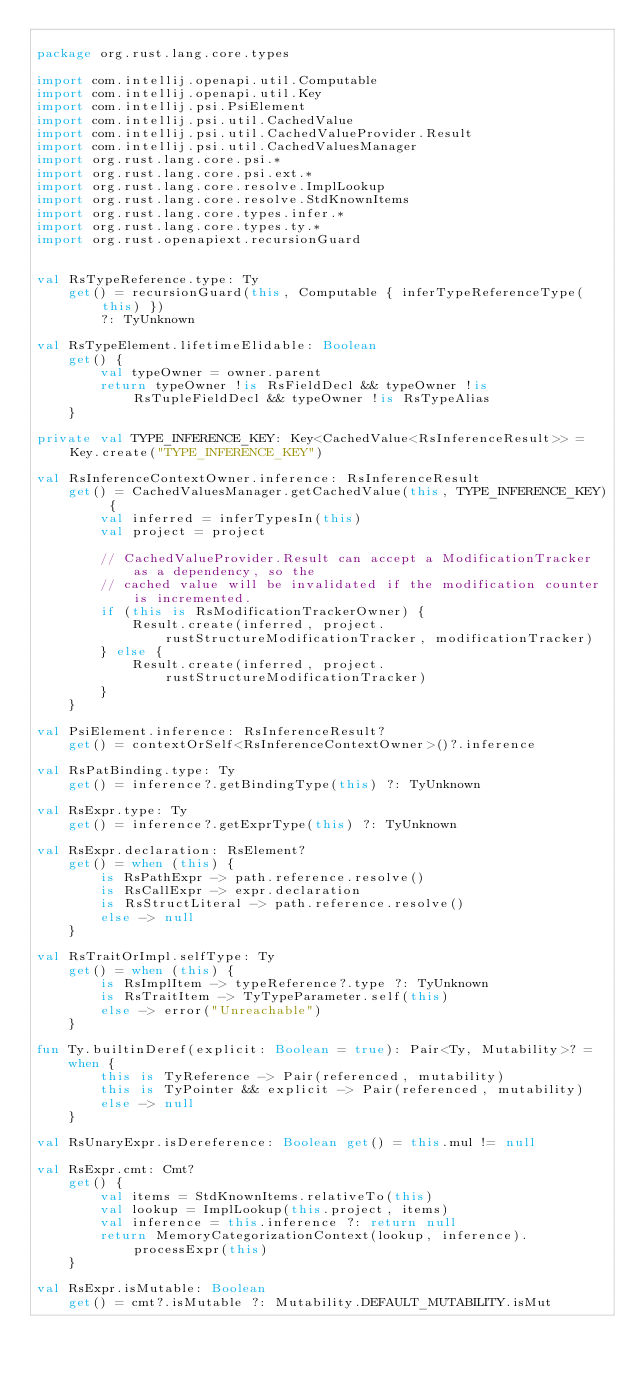Convert code to text. <code><loc_0><loc_0><loc_500><loc_500><_Kotlin_>
package org.rust.lang.core.types

import com.intellij.openapi.util.Computable
import com.intellij.openapi.util.Key
import com.intellij.psi.PsiElement
import com.intellij.psi.util.CachedValue
import com.intellij.psi.util.CachedValueProvider.Result
import com.intellij.psi.util.CachedValuesManager
import org.rust.lang.core.psi.*
import org.rust.lang.core.psi.ext.*
import org.rust.lang.core.resolve.ImplLookup
import org.rust.lang.core.resolve.StdKnownItems
import org.rust.lang.core.types.infer.*
import org.rust.lang.core.types.ty.*
import org.rust.openapiext.recursionGuard


val RsTypeReference.type: Ty
    get() = recursionGuard(this, Computable { inferTypeReferenceType(this) })
        ?: TyUnknown

val RsTypeElement.lifetimeElidable: Boolean
    get() {
        val typeOwner = owner.parent
        return typeOwner !is RsFieldDecl && typeOwner !is RsTupleFieldDecl && typeOwner !is RsTypeAlias
    }

private val TYPE_INFERENCE_KEY: Key<CachedValue<RsInferenceResult>> = Key.create("TYPE_INFERENCE_KEY")

val RsInferenceContextOwner.inference: RsInferenceResult
    get() = CachedValuesManager.getCachedValue(this, TYPE_INFERENCE_KEY) {
        val inferred = inferTypesIn(this)
        val project = project

        // CachedValueProvider.Result can accept a ModificationTracker as a dependency, so the
        // cached value will be invalidated if the modification counter is incremented.
        if (this is RsModificationTrackerOwner) {
            Result.create(inferred, project.rustStructureModificationTracker, modificationTracker)
        } else {
            Result.create(inferred, project.rustStructureModificationTracker)
        }
    }

val PsiElement.inference: RsInferenceResult?
    get() = contextOrSelf<RsInferenceContextOwner>()?.inference

val RsPatBinding.type: Ty
    get() = inference?.getBindingType(this) ?: TyUnknown

val RsExpr.type: Ty
    get() = inference?.getExprType(this) ?: TyUnknown

val RsExpr.declaration: RsElement?
    get() = when (this) {
        is RsPathExpr -> path.reference.resolve()
        is RsCallExpr -> expr.declaration
        is RsStructLiteral -> path.reference.resolve()
        else -> null
    }

val RsTraitOrImpl.selfType: Ty
    get() = when (this) {
        is RsImplItem -> typeReference?.type ?: TyUnknown
        is RsTraitItem -> TyTypeParameter.self(this)
        else -> error("Unreachable")
    }

fun Ty.builtinDeref(explicit: Boolean = true): Pair<Ty, Mutability>? =
    when {
        this is TyReference -> Pair(referenced, mutability)
        this is TyPointer && explicit -> Pair(referenced, mutability)
        else -> null
    }

val RsUnaryExpr.isDereference: Boolean get() = this.mul != null

val RsExpr.cmt: Cmt?
    get() {
        val items = StdKnownItems.relativeTo(this)
        val lookup = ImplLookup(this.project, items)
        val inference = this.inference ?: return null
        return MemoryCategorizationContext(lookup, inference).processExpr(this)
    }

val RsExpr.isMutable: Boolean
    get() = cmt?.isMutable ?: Mutability.DEFAULT_MUTABILITY.isMut
</code> 